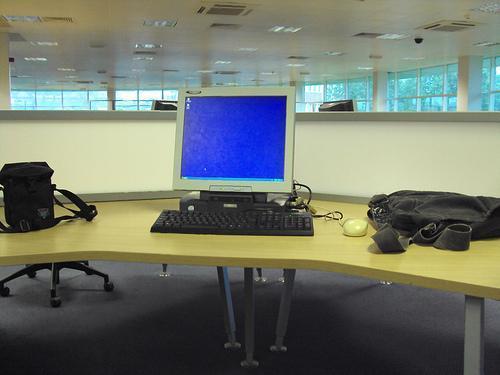How many black bags are on the left of the computer?
Give a very brief answer. 1. 